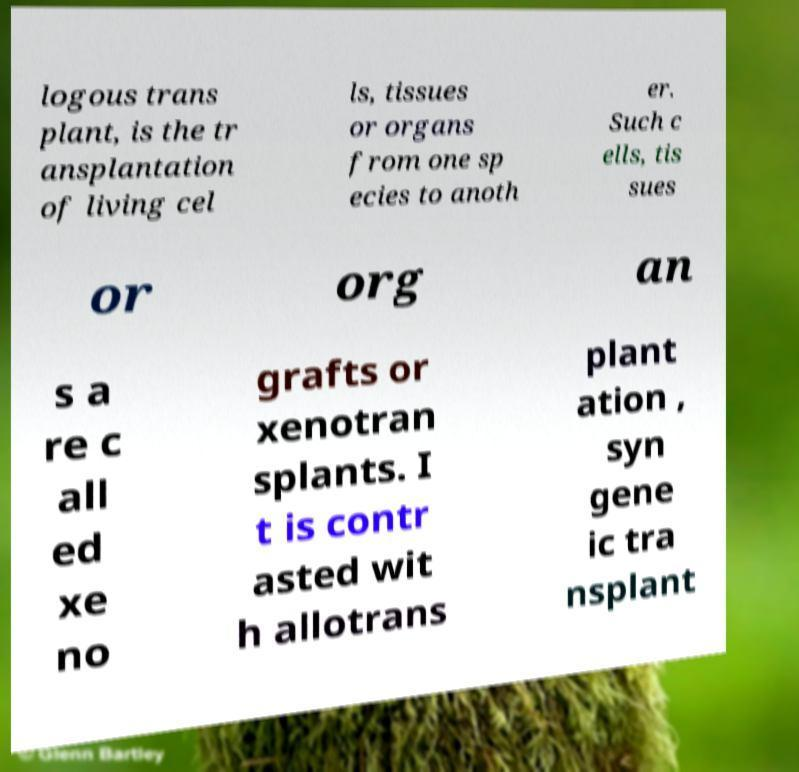Please read and relay the text visible in this image. What does it say? logous trans plant, is the tr ansplantation of living cel ls, tissues or organs from one sp ecies to anoth er. Such c ells, tis sues or org an s a re c all ed xe no grafts or xenotran splants. I t is contr asted wit h allotrans plant ation , syn gene ic tra nsplant 